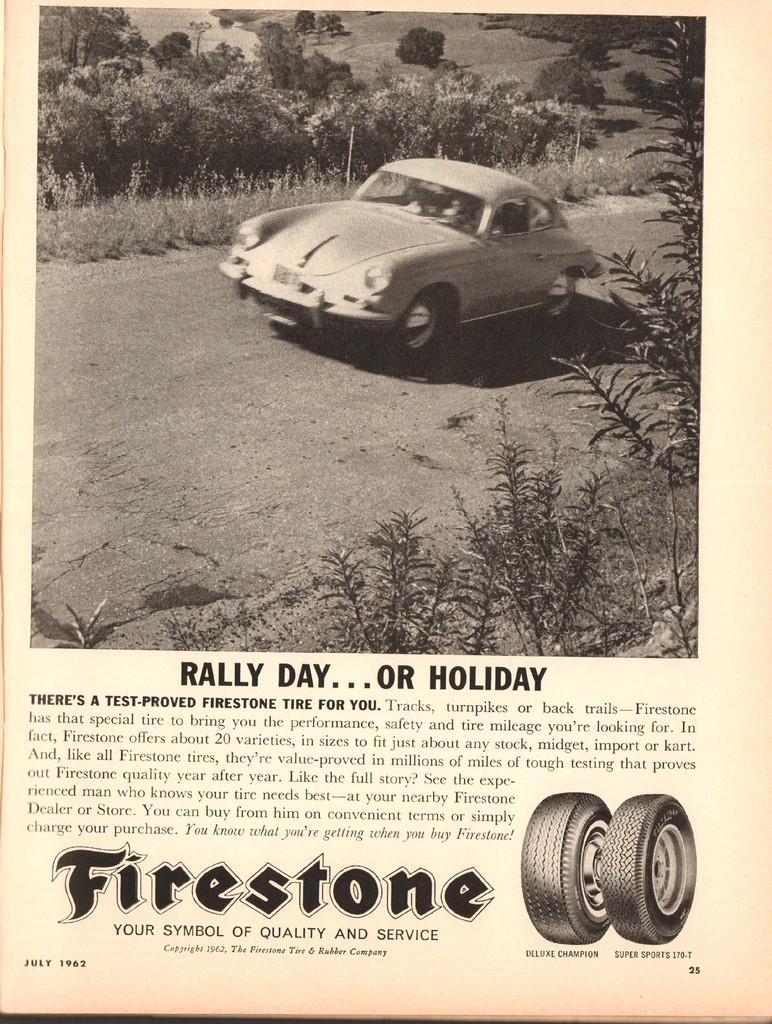Please provide a concise description of this image. This looks like a poster. I can see the picture of a car on the road. These are the trees and plants. I can see the letters on the image. There are two wheels. 